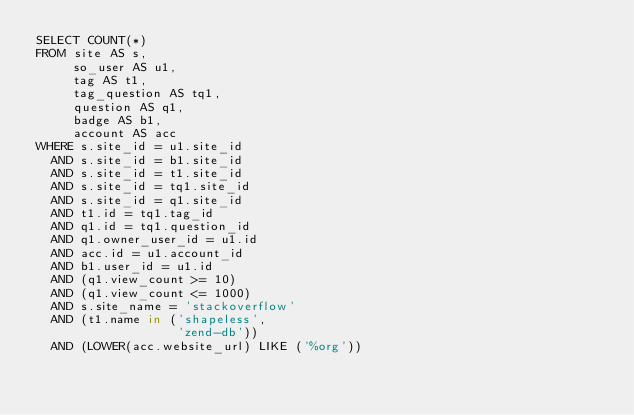<code> <loc_0><loc_0><loc_500><loc_500><_SQL_>SELECT COUNT(*)
FROM site AS s,
     so_user AS u1,
     tag AS t1,
     tag_question AS tq1,
     question AS q1,
     badge AS b1,
     account AS acc
WHERE s.site_id = u1.site_id
  AND s.site_id = b1.site_id
  AND s.site_id = t1.site_id
  AND s.site_id = tq1.site_id
  AND s.site_id = q1.site_id
  AND t1.id = tq1.tag_id
  AND q1.id = tq1.question_id
  AND q1.owner_user_id = u1.id
  AND acc.id = u1.account_id
  AND b1.user_id = u1.id
  AND (q1.view_count >= 10)
  AND (q1.view_count <= 1000)
  AND s.site_name = 'stackoverflow'
  AND (t1.name in ('shapeless',
                   'zend-db'))
  AND (LOWER(acc.website_url) LIKE ('%org'))</code> 